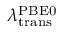<formula> <loc_0><loc_0><loc_500><loc_500>\lambda _ { t r a n s } ^ { P B E 0 }</formula> 